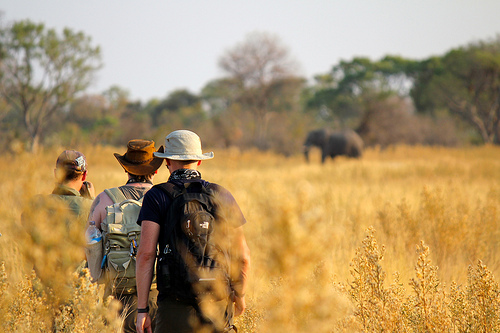Of which color is the cap? The cap is brown. 